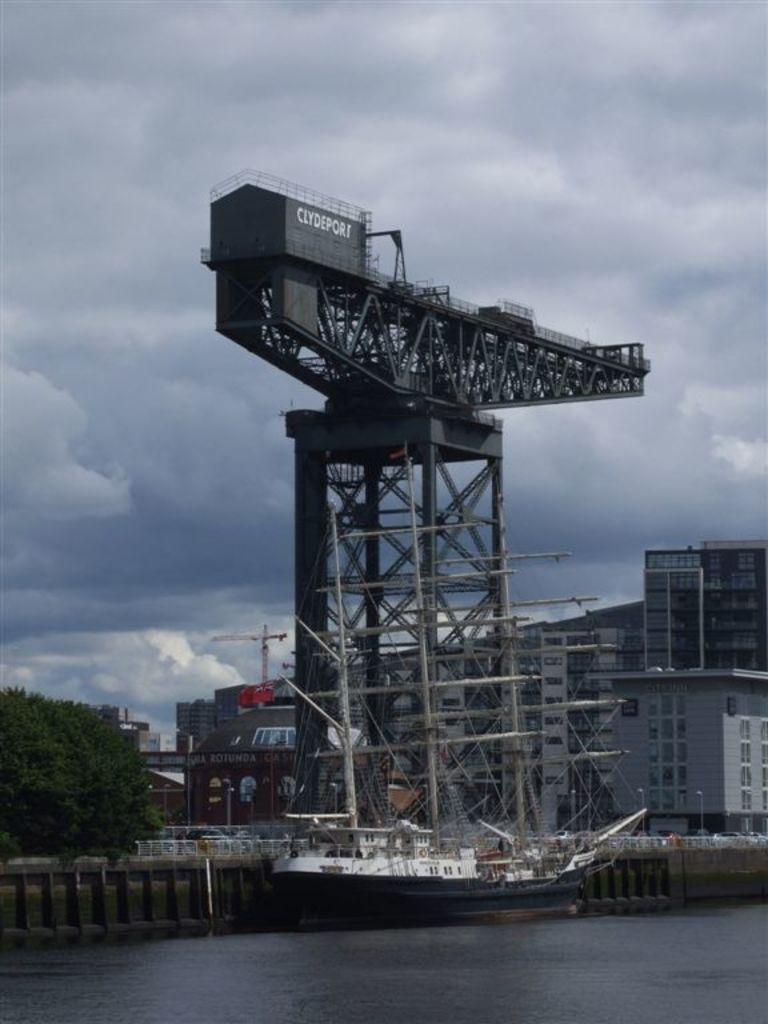How would you summarize this image in a sentence or two? In the center of the image we can see tower, buildings, tree, boat, bridge and some persons are there. At the bottom of the image water is there. At the top of the image clouds are present in the sky. 